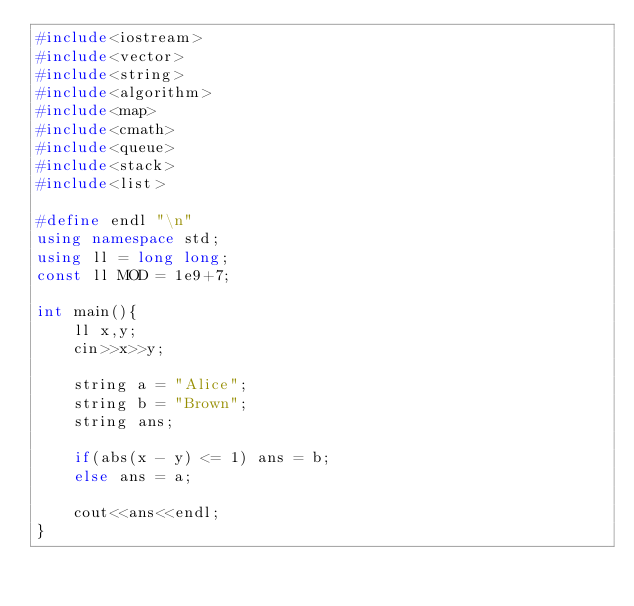Convert code to text. <code><loc_0><loc_0><loc_500><loc_500><_C++_>#include<iostream>
#include<vector>
#include<string>
#include<algorithm>
#include<map>
#include<cmath>
#include<queue>
#include<stack>
#include<list>

#define endl "\n"
using namespace std;
using ll = long long;
const ll MOD = 1e9+7;

int main(){
    ll x,y;
    cin>>x>>y;

    string a = "Alice";
    string b = "Brown";
    string ans;

    if(abs(x - y) <= 1) ans = b;
    else ans = a;

    cout<<ans<<endl;
}</code> 